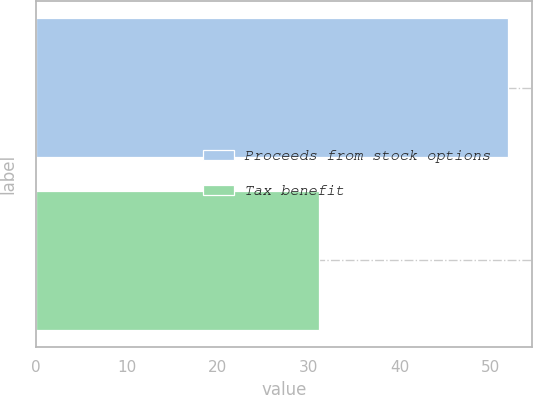Convert chart. <chart><loc_0><loc_0><loc_500><loc_500><bar_chart><fcel>Proceeds from stock options<fcel>Tax benefit<nl><fcel>52<fcel>31.1<nl></chart> 